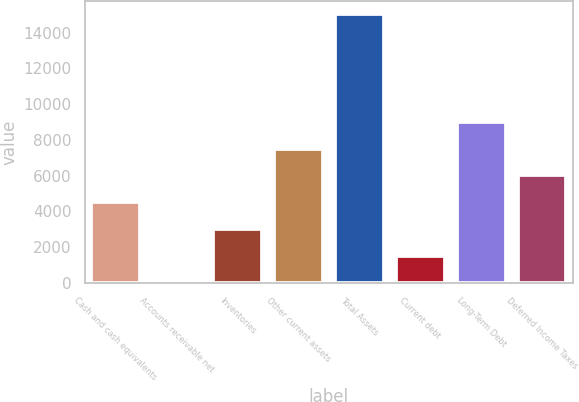<chart> <loc_0><loc_0><loc_500><loc_500><bar_chart><fcel>Cash and cash equivalents<fcel>Accounts receivable net<fcel>Inventories<fcel>Other current assets<fcel>Total Assets<fcel>Current debt<fcel>Long-Term Debt<fcel>Deferred Income Taxes<nl><fcel>4509.7<fcel>1<fcel>3006.8<fcel>7515.5<fcel>15030<fcel>1503.9<fcel>9018.4<fcel>6012.6<nl></chart> 